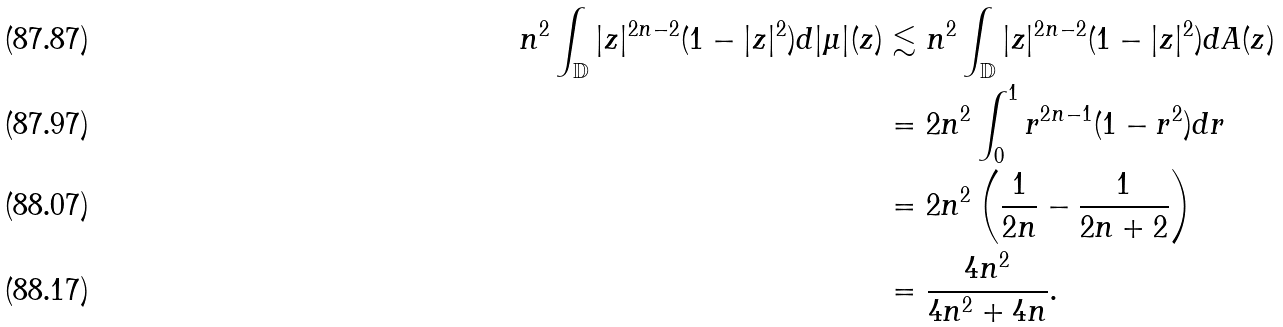<formula> <loc_0><loc_0><loc_500><loc_500>n ^ { 2 } \int _ { \mathbb { D } } | z | ^ { 2 n - 2 } ( 1 - | z | ^ { 2 } ) d | \mu | ( z ) & \lesssim n ^ { 2 } \int _ { \mathbb { D } } | z | ^ { 2 n - 2 } ( 1 - | z | ^ { 2 } ) d A ( z ) \\ & = 2 n ^ { 2 } \int _ { 0 } ^ { 1 } r ^ { 2 n - 1 } ( 1 - r ^ { 2 } ) d r \\ & = 2 n ^ { 2 } \left ( \frac { 1 } { 2 n } - \frac { 1 } { 2 n + 2 } \right ) \\ & = \frac { 4 n ^ { 2 } } { 4 n ^ { 2 } + 4 n } .</formula> 